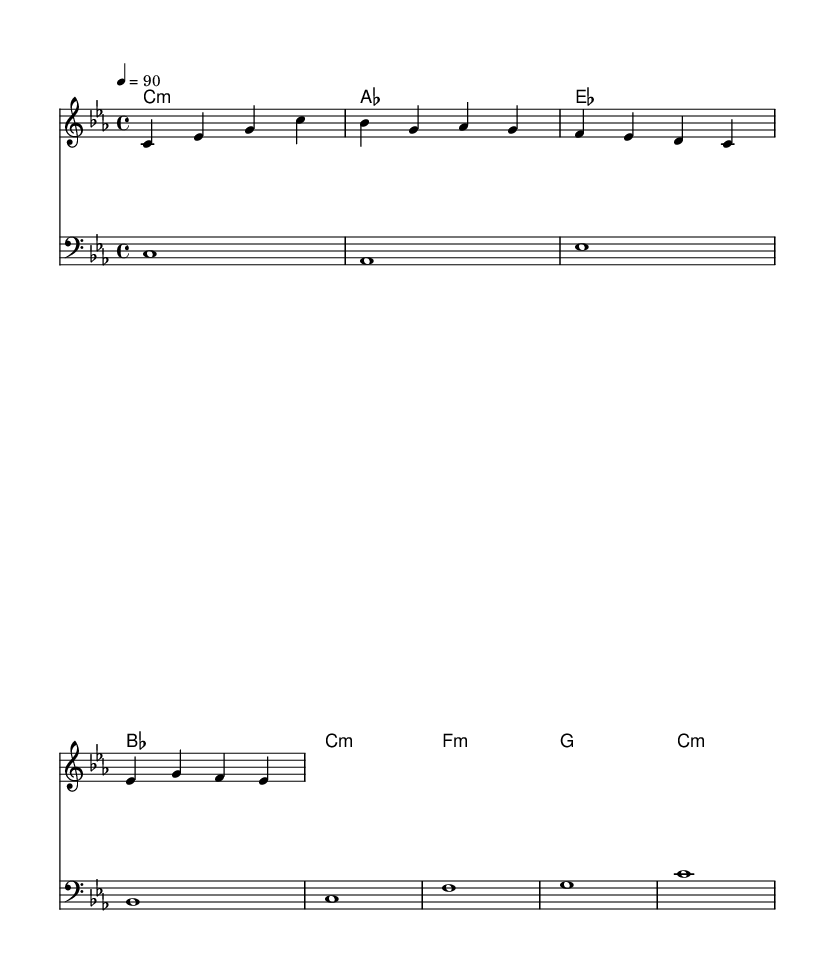What is the key signature of this music? The key signature is C minor, which has three flats (B flat, E flat, and A flat). This can be inferred from the musical context and the indicated notes.
Answer: C minor What is the time signature of this music? The time signature is 4/4, indicated clearly at the beginning of the score. This means there are four beats in a measure, and the quarter note gets one beat.
Answer: 4/4 What is the tempo marking for this music? The tempo marking is quarter note equals 90, indicating that the piece should be played at a moderate speed of 90 beats per minute.
Answer: 90 What record label is mentioned in the lyrics? The record label mentioned is Caedmon Records, which is recognized for its contributions to literature and spoken word in audio format.
Answer: Caedmon Records How many chords are in the chord progression? There are four chords in the chord progression: C minor, A flat major, B flat major, and F minor. These chords are combined in a pattern to support the melody.
Answer: Four What is the theme of the lyrics? The theme of the lyrics centers around celebrating Marianne Mantell as a pioneer in sound and her contributions to literature through music records, highlighting her legacy.
Answer: Celebrating imaginative contributions 